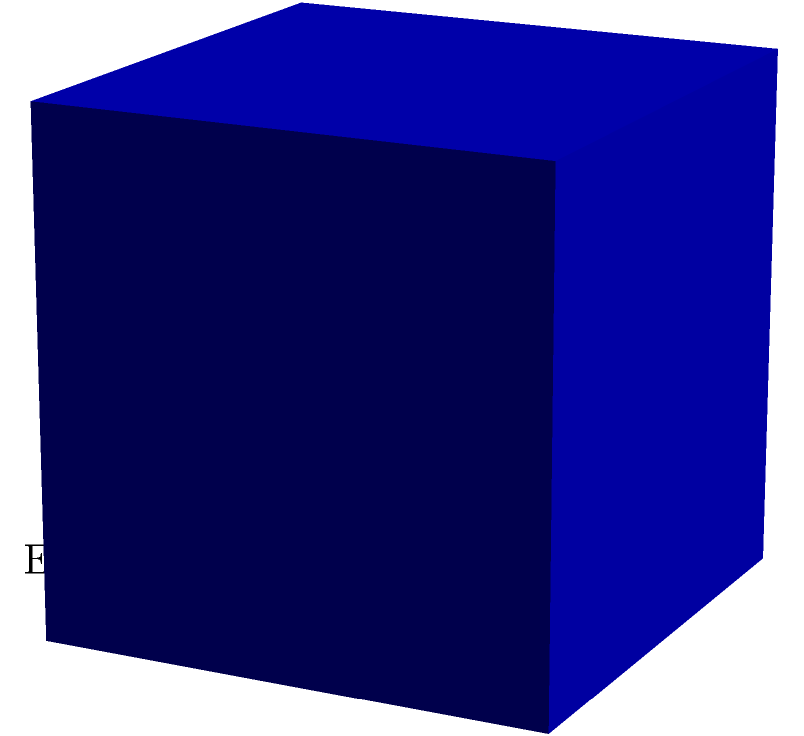As a guitarist, you're designing a custom cube-shaped effects pedal. If the edge length of the pedal is 4 inches, what is the total surface area of the pedal's casing? Let's approach this step-by-step:

1) The shape of the effects pedal is a cube. A cube has 6 identical square faces.

2) The surface area of a cube is the sum of the areas of all its faces.

3) The area of one face is given by the square of its edge length:
   Area of one face = $a^2$, where $a$ is the edge length

4) Given: The edge length $a = 4$ inches

5) Area of one face = $4^2 = 16$ square inches

6) Since there are 6 identical faces, we multiply the area of one face by 6:
   Total surface area = $6 * 16 = 96$ square inches

Therefore, the total surface area of the cube-shaped effects pedal is 96 square inches.
Answer: 96 square inches 